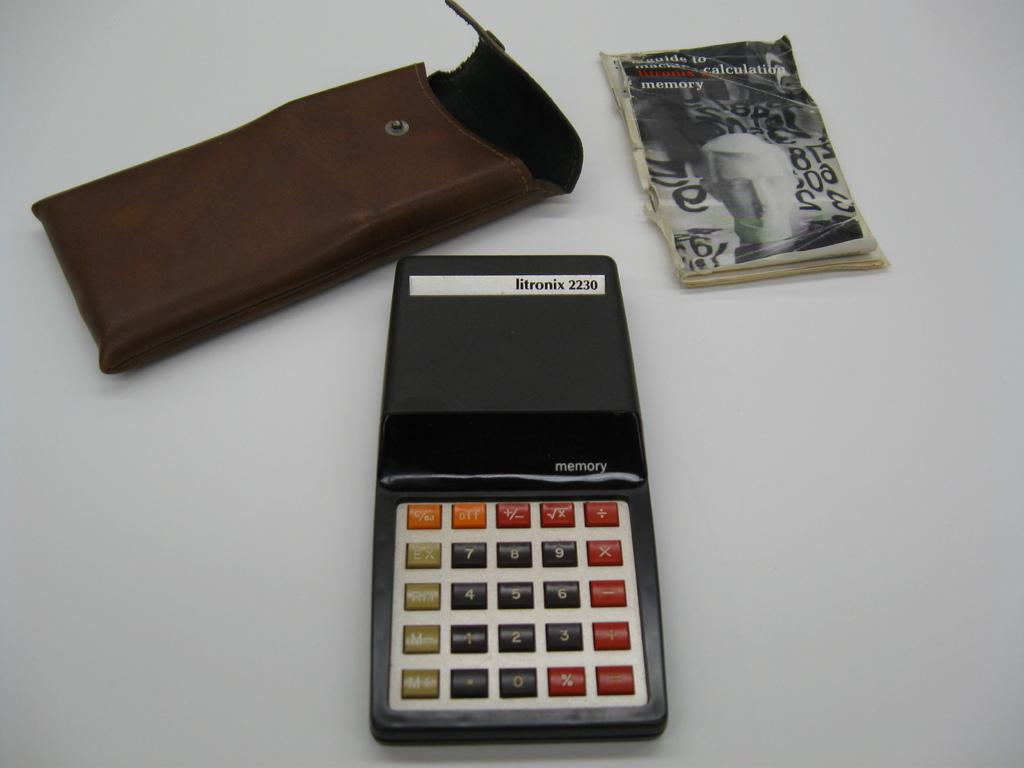<image>
Relay a brief, clear account of the picture shown. A Litronix calculator with its holder and guide. 